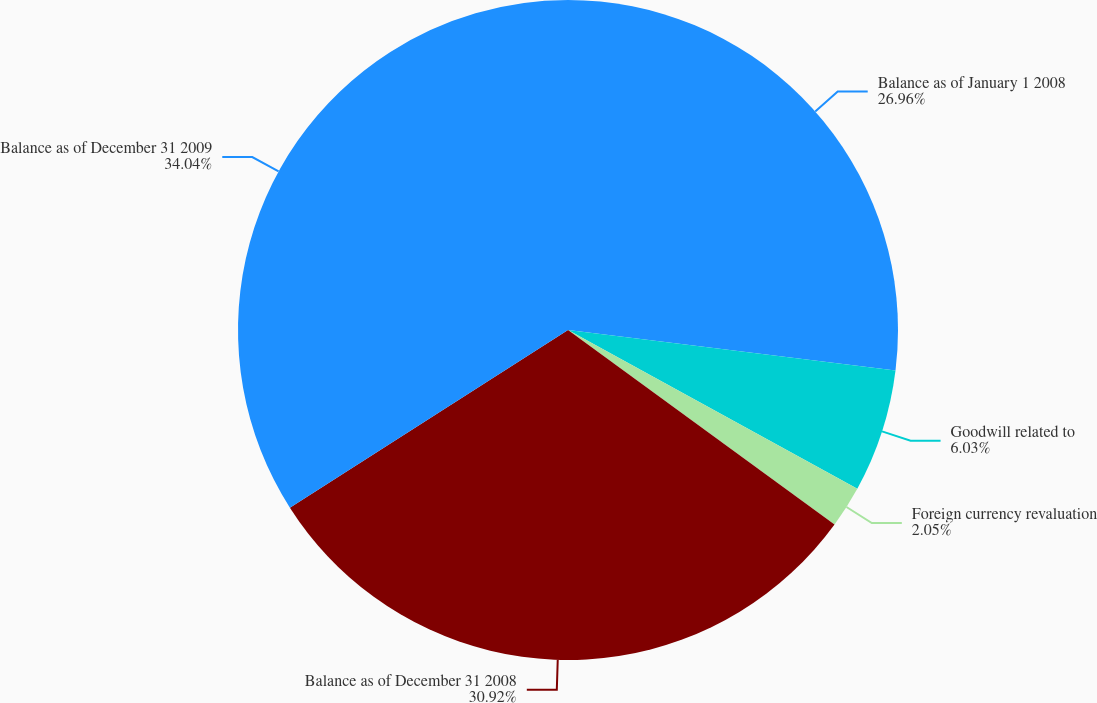Convert chart to OTSL. <chart><loc_0><loc_0><loc_500><loc_500><pie_chart><fcel>Balance as of January 1 2008<fcel>Goodwill related to<fcel>Foreign currency revaluation<fcel>Balance as of December 31 2008<fcel>Balance as of December 31 2009<nl><fcel>26.96%<fcel>6.03%<fcel>2.05%<fcel>30.92%<fcel>34.05%<nl></chart> 